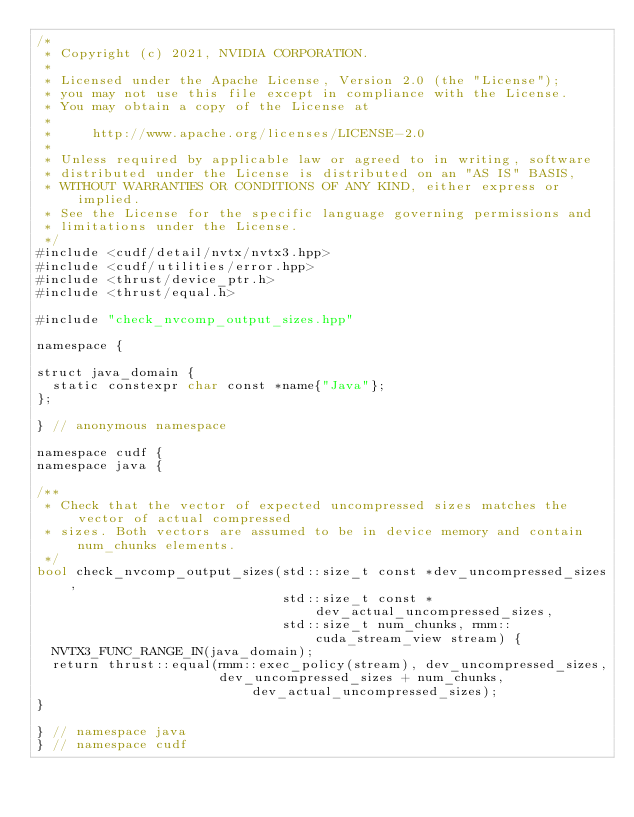Convert code to text. <code><loc_0><loc_0><loc_500><loc_500><_Cuda_>/*
 * Copyright (c) 2021, NVIDIA CORPORATION.
 *
 * Licensed under the Apache License, Version 2.0 (the "License");
 * you may not use this file except in compliance with the License.
 * You may obtain a copy of the License at
 *
 *     http://www.apache.org/licenses/LICENSE-2.0
 *
 * Unless required by applicable law or agreed to in writing, software
 * distributed under the License is distributed on an "AS IS" BASIS,
 * WITHOUT WARRANTIES OR CONDITIONS OF ANY KIND, either express or implied.
 * See the License for the specific language governing permissions and
 * limitations under the License.
 */
#include <cudf/detail/nvtx/nvtx3.hpp>
#include <cudf/utilities/error.hpp>
#include <thrust/device_ptr.h>
#include <thrust/equal.h>

#include "check_nvcomp_output_sizes.hpp"

namespace {

struct java_domain {
  static constexpr char const *name{"Java"};
};

} // anonymous namespace

namespace cudf {
namespace java {

/**
 * Check that the vector of expected uncompressed sizes matches the vector of actual compressed
 * sizes. Both vectors are assumed to be in device memory and contain num_chunks elements.
 */
bool check_nvcomp_output_sizes(std::size_t const *dev_uncompressed_sizes,
                               std::size_t const *dev_actual_uncompressed_sizes,
                               std::size_t num_chunks, rmm::cuda_stream_view stream) {
  NVTX3_FUNC_RANGE_IN(java_domain);
  return thrust::equal(rmm::exec_policy(stream), dev_uncompressed_sizes,
                       dev_uncompressed_sizes + num_chunks, dev_actual_uncompressed_sizes);
}

} // namespace java
} // namespace cudf
</code> 